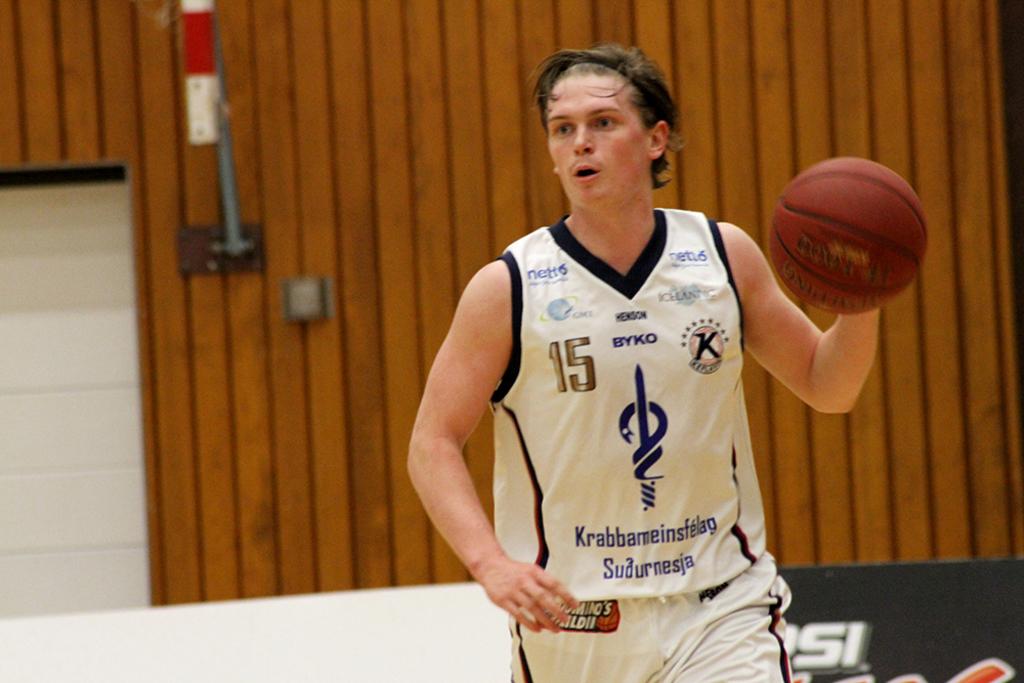Who is one of the sponsors on his jersey?
Your response must be concise. Byko. 